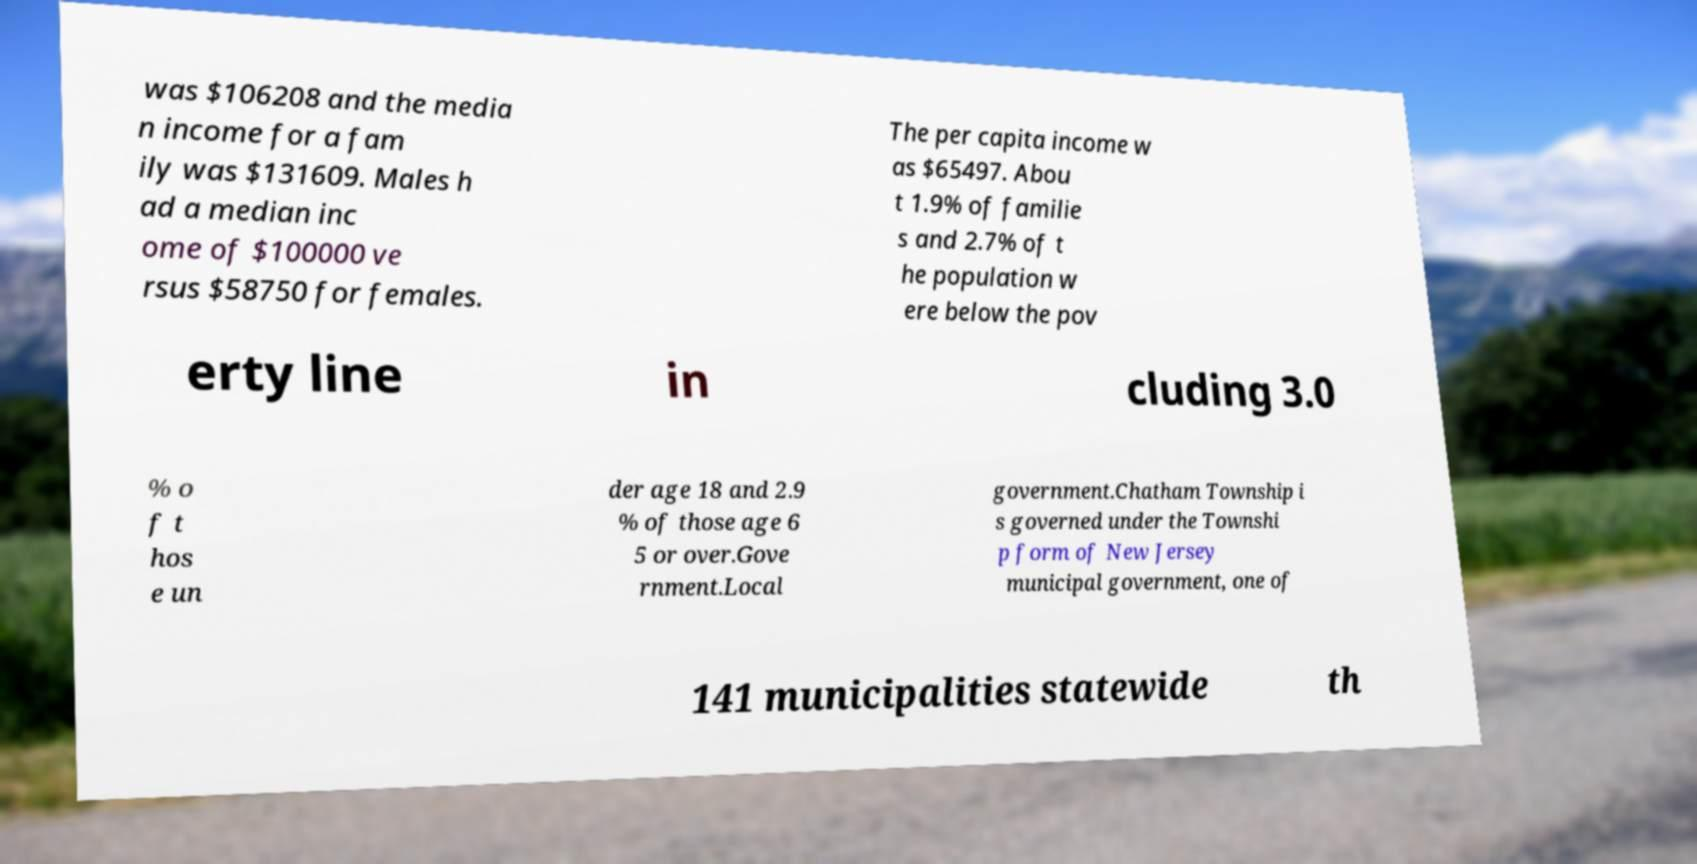What messages or text are displayed in this image? I need them in a readable, typed format. was $106208 and the media n income for a fam ily was $131609. Males h ad a median inc ome of $100000 ve rsus $58750 for females. The per capita income w as $65497. Abou t 1.9% of familie s and 2.7% of t he population w ere below the pov erty line in cluding 3.0 % o f t hos e un der age 18 and 2.9 % of those age 6 5 or over.Gove rnment.Local government.Chatham Township i s governed under the Townshi p form of New Jersey municipal government, one of 141 municipalities statewide th 